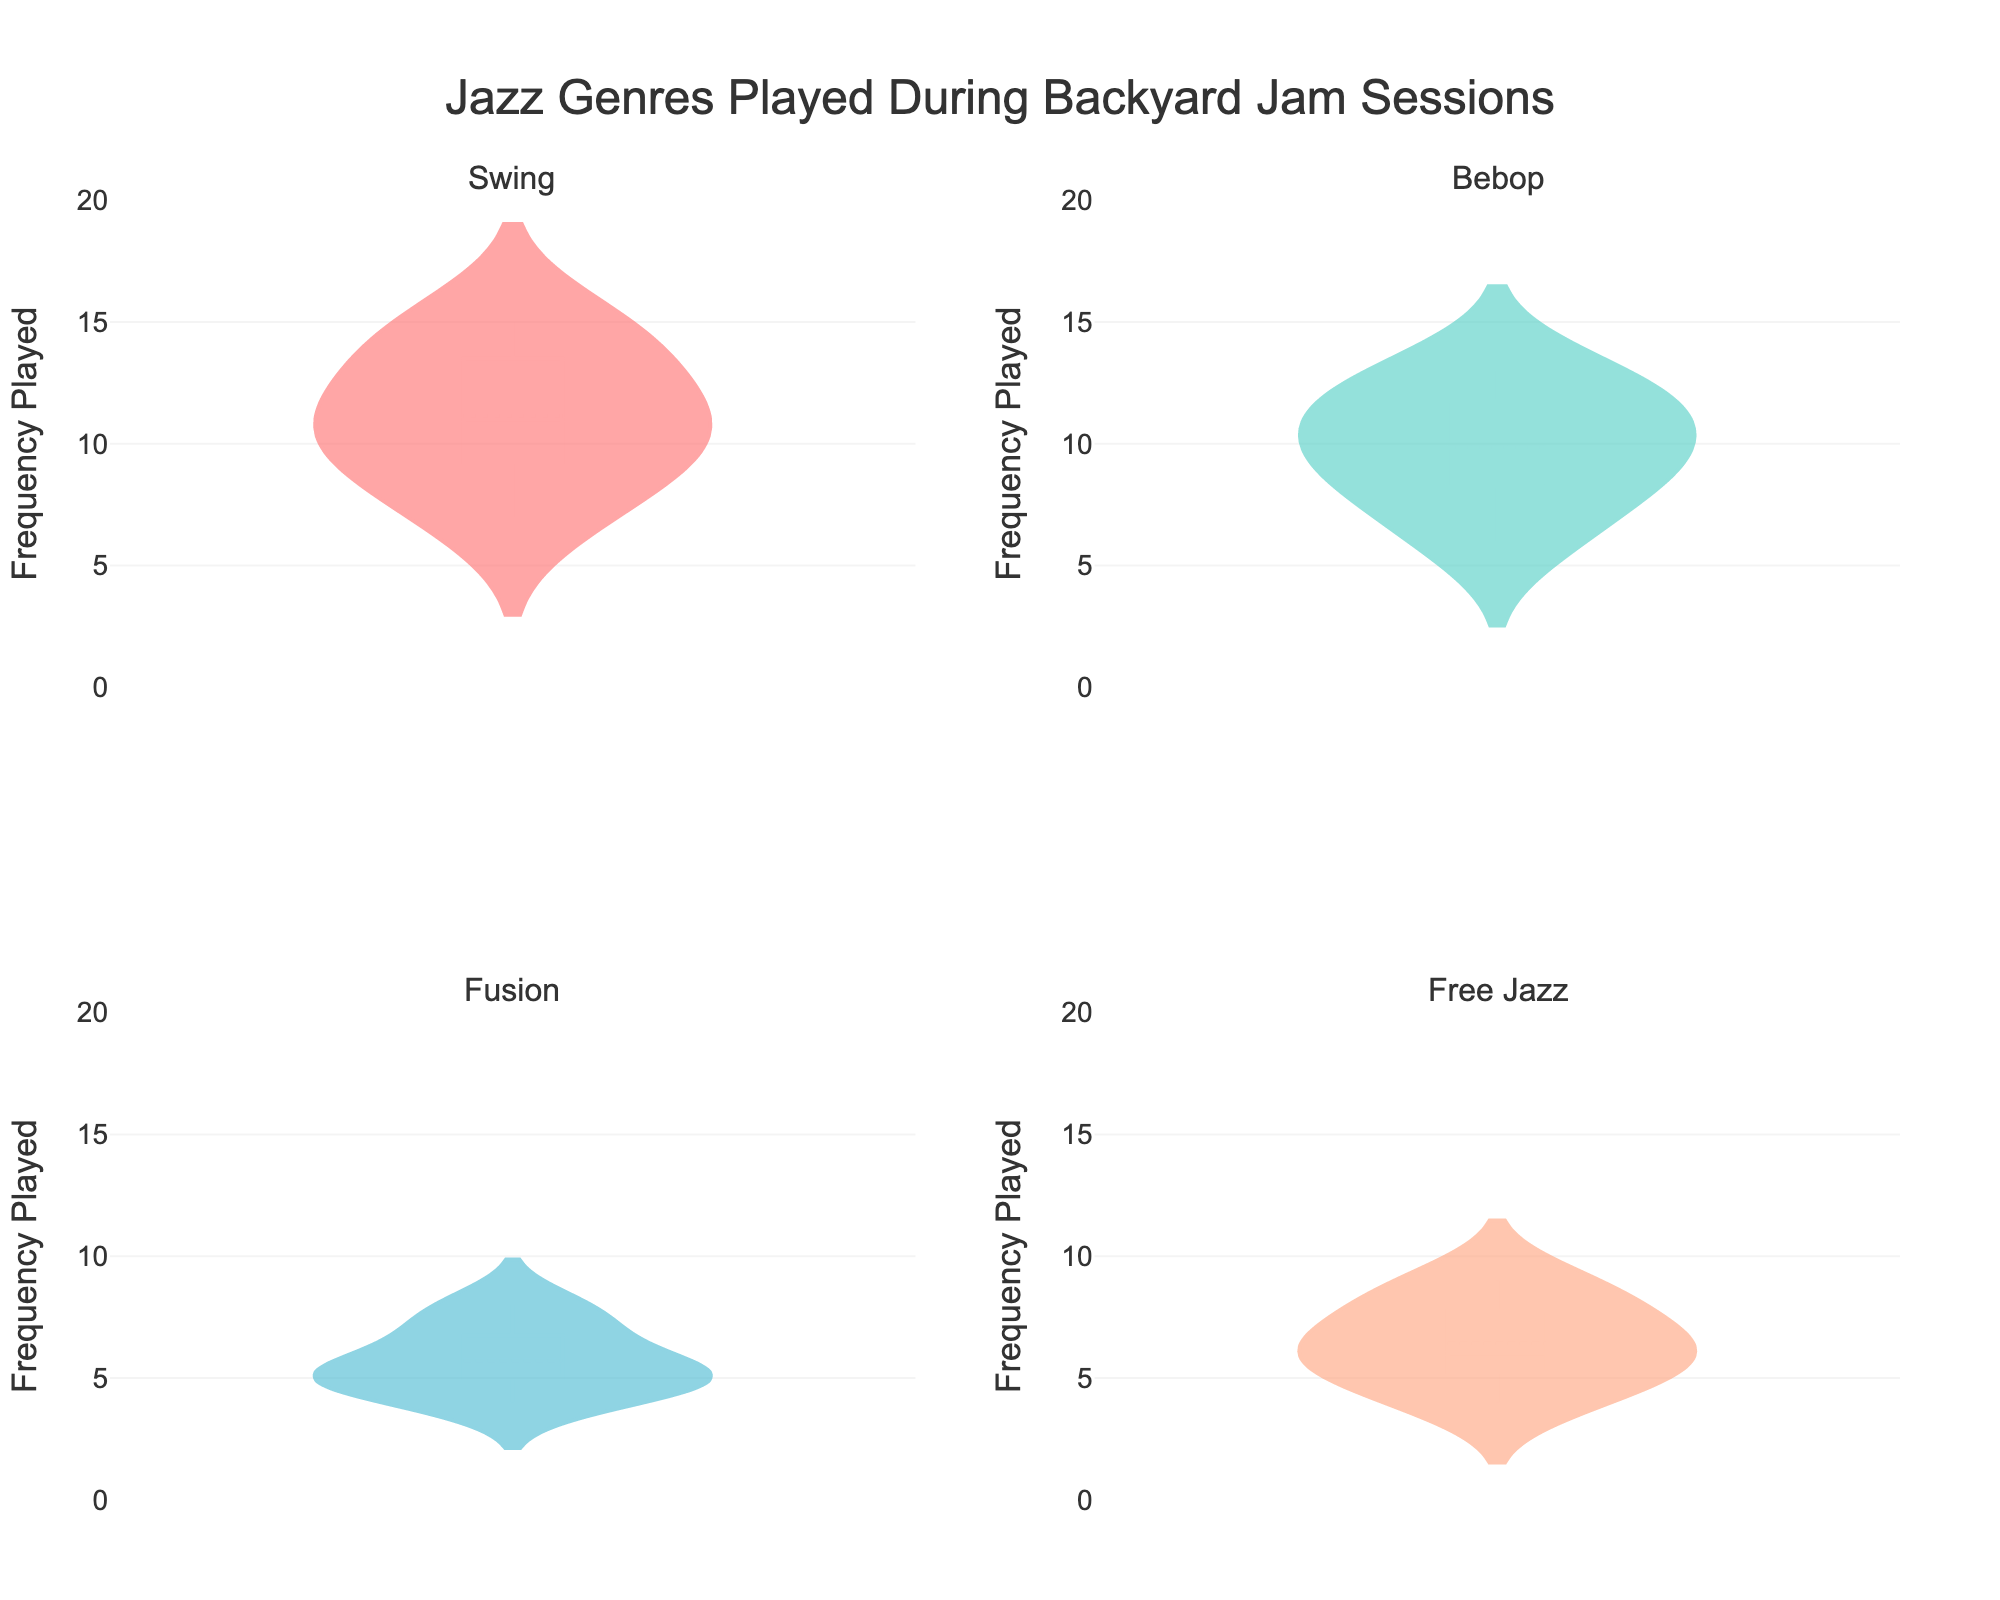What's the title of the figure? The title is typically written at the top of the figure. In this case, it is specified in the code as "Jazz Genres Played During Backyard Jam Sessions".
Answer: Jazz Genres Played During Backyard Jam Sessions Which genre has the widest distribution of frequencies played in the subplots? A wide distribution in a violin plot will look wider compared to others. By comparing all four subplots, "Swing" has the widest distribution of frequencies.
Answer: Swing What is the range of frequencies played for Bebop? The y-axis for each subplot shows the range of frequencies. For Bebop, it ranges from 6 to 13.
Answer: 6 to 13 Which genre has the highest median frequency played? The median is indicated by a horizontal line within the violin plot. Comparing all four genres, "Swing" has the highest median frequency played.
Answer: Swing What is the average frequency played for Free Jazz? To find the average frequency, look at individual values in the subplot and calculate their mean. Free Jazz values: 4, 7, 5, 8, 6, 6, 9. The sum is 45, and there are 7 data points, so the average is 45 / 7 ≈ 6.43.
Answer: 6.43 Which genre is played the least frequently and how do you determine it? Find the lowest frequency values in each subplot. For "Free Jazz", the lowest value is 4, which is the lowest among all genres.
Answer: Free Jazz; determined by the lowest value being 4 Compare the distributions of Fusion and Bebop. Which has a higher variability in frequency played? Variability is seen in the spread of the distribution. Bebop's distribution is wider from 6 to 13, while Fusion ranges from 4 to 8, indicating Bebop has higher variability.
Answer: Bebop Which genre shows the least variability in frequency played? The least variability will have the narrowest distribution. Comparing subplots, "Fusion" shows the narrowest distribution from 4 to 8.
Answer: Fusion Are there any genres that have a mean frequency lower than 7? The mean line in the violin plot helps identify this. For "Free Jazz" and "Fusion", the position of the mean line indicates that their mean frequency is lower than 7.
Answer: Yes; Free Jazz and Fusion Compare the frequencies played for Swing and Free Jazz in Session 3. Which one is higher? From the data, for Session 3, Swing is played 15 times while Free Jazz is played 5 times.
Answer: Swing 